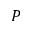<formula> <loc_0><loc_0><loc_500><loc_500>P</formula> 